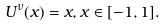Convert formula to latex. <formula><loc_0><loc_0><loc_500><loc_500>U ^ { \nu } ( x ) = x , x \in [ - 1 , 1 ] .</formula> 